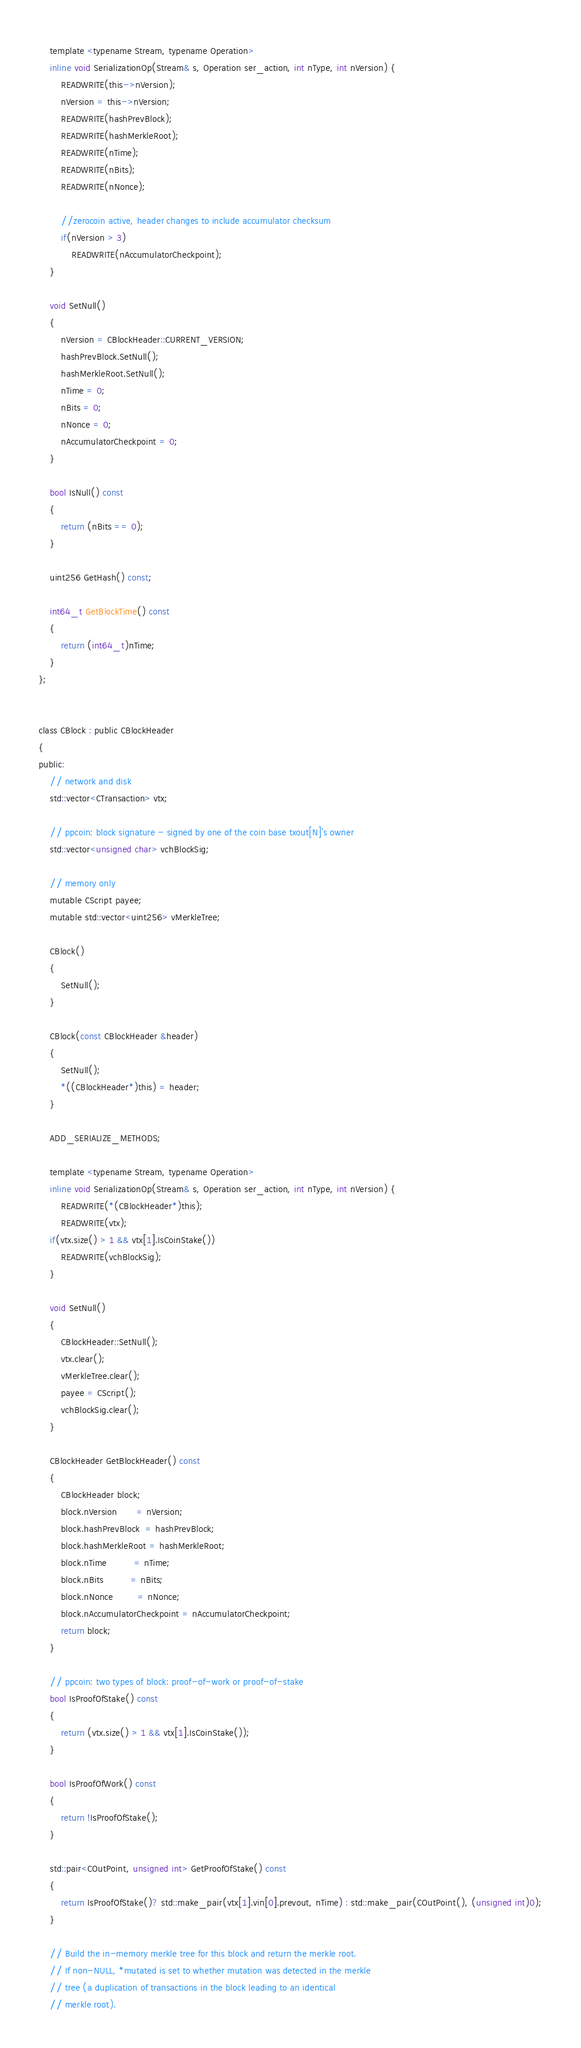Convert code to text. <code><loc_0><loc_0><loc_500><loc_500><_C_>    template <typename Stream, typename Operation>
    inline void SerializationOp(Stream& s, Operation ser_action, int nType, int nVersion) {
        READWRITE(this->nVersion);
        nVersion = this->nVersion;
        READWRITE(hashPrevBlock);
        READWRITE(hashMerkleRoot);
        READWRITE(nTime);
        READWRITE(nBits);
        READWRITE(nNonce);

        //zerocoin active, header changes to include accumulator checksum
        if(nVersion > 3)
            READWRITE(nAccumulatorCheckpoint);
    }

    void SetNull()
    {
        nVersion = CBlockHeader::CURRENT_VERSION;
        hashPrevBlock.SetNull();
        hashMerkleRoot.SetNull();
        nTime = 0;
        nBits = 0;
        nNonce = 0;
        nAccumulatorCheckpoint = 0;
    }

    bool IsNull() const
    {
        return (nBits == 0);
    }

    uint256 GetHash() const;

    int64_t GetBlockTime() const
    {
        return (int64_t)nTime;
    }
};


class CBlock : public CBlockHeader
{
public:
    // network and disk
    std::vector<CTransaction> vtx;

    // ppcoin: block signature - signed by one of the coin base txout[N]'s owner
    std::vector<unsigned char> vchBlockSig;

    // memory only
    mutable CScript payee;
    mutable std::vector<uint256> vMerkleTree;

    CBlock()
    {
        SetNull();
    }

    CBlock(const CBlockHeader &header)
    {
        SetNull();
        *((CBlockHeader*)this) = header;
    }

    ADD_SERIALIZE_METHODS;

    template <typename Stream, typename Operation>
    inline void SerializationOp(Stream& s, Operation ser_action, int nType, int nVersion) {
        READWRITE(*(CBlockHeader*)this);
        READWRITE(vtx);
	if(vtx.size() > 1 && vtx[1].IsCoinStake())
		READWRITE(vchBlockSig);
    }

    void SetNull()
    {
        CBlockHeader::SetNull();
        vtx.clear();
        vMerkleTree.clear();
        payee = CScript();
        vchBlockSig.clear();
    }

    CBlockHeader GetBlockHeader() const
    {
        CBlockHeader block;
        block.nVersion       = nVersion;
        block.hashPrevBlock  = hashPrevBlock;
        block.hashMerkleRoot = hashMerkleRoot;
        block.nTime          = nTime;
        block.nBits          = nBits;
        block.nNonce         = nNonce;
        block.nAccumulatorCheckpoint = nAccumulatorCheckpoint;
        return block;
    }

    // ppcoin: two types of block: proof-of-work or proof-of-stake
    bool IsProofOfStake() const
    {
        return (vtx.size() > 1 && vtx[1].IsCoinStake());
    }

    bool IsProofOfWork() const
    {
        return !IsProofOfStake();
    }

    std::pair<COutPoint, unsigned int> GetProofOfStake() const
    {
        return IsProofOfStake()? std::make_pair(vtx[1].vin[0].prevout, nTime) : std::make_pair(COutPoint(), (unsigned int)0);
    }

    // Build the in-memory merkle tree for this block and return the merkle root.
    // If non-NULL, *mutated is set to whether mutation was detected in the merkle
    // tree (a duplication of transactions in the block leading to an identical
    // merkle root).</code> 